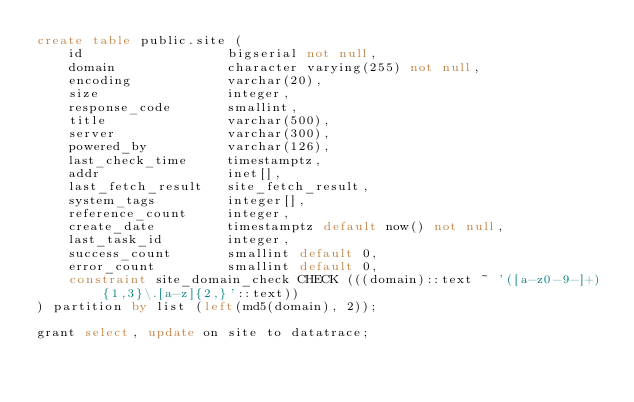Convert code to text. <code><loc_0><loc_0><loc_500><loc_500><_SQL_>create table public.site (
    id                  bigserial not null,
    domain              character varying(255) not null,
    encoding            varchar(20),
    size                integer,
    response_code       smallint,
    title               varchar(500),
    server              varchar(300),
    powered_by          varchar(126),
    last_check_time     timestamptz,
    addr                inet[],
    last_fetch_result   site_fetch_result,
    system_tags         integer[],
    reference_count     integer,
    create_date         timestamptz default now() not null,
    last_task_id        integer,
    success_count       smallint default 0,
    error_count         smallint default 0,
    constraint site_domain_check CHECK (((domain)::text ~ '([a-z0-9-]+){1,3}\.[a-z]{2,}'::text))
) partition by list (left(md5(domain), 2));

grant select, update on site to datatrace;
</code> 